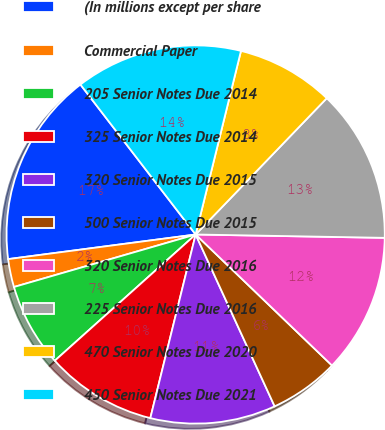Convert chart to OTSL. <chart><loc_0><loc_0><loc_500><loc_500><pie_chart><fcel>(In millions except per share<fcel>Commercial Paper<fcel>205 Senior Notes Due 2014<fcel>325 Senior Notes Due 2014<fcel>320 Senior Notes Due 2015<fcel>500 Senior Notes Due 2015<fcel>320 Senior Notes Due 2016<fcel>225 Senior Notes Due 2016<fcel>470 Senior Notes Due 2020<fcel>450 Senior Notes Due 2021<nl><fcel>16.65%<fcel>2.4%<fcel>7.15%<fcel>9.52%<fcel>10.71%<fcel>5.96%<fcel>11.9%<fcel>13.09%<fcel>8.34%<fcel>14.28%<nl></chart> 